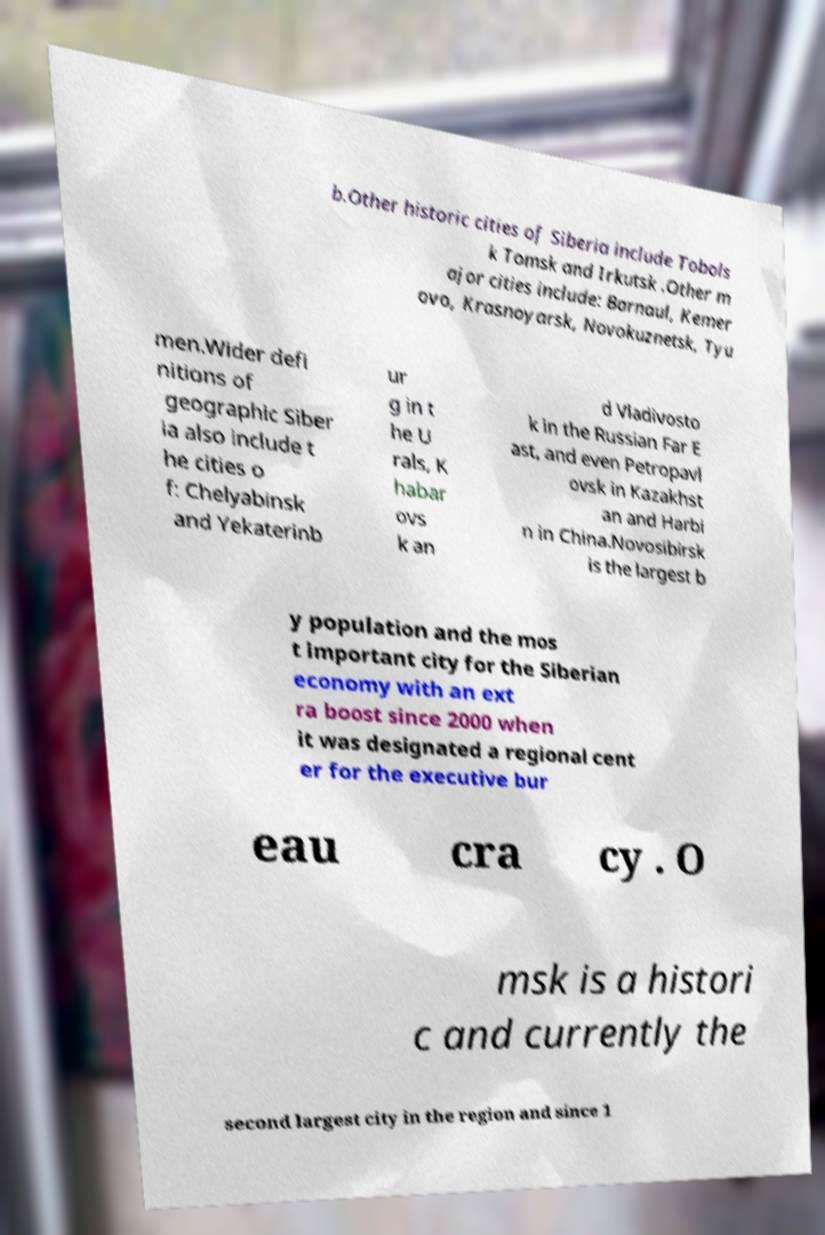Please read and relay the text visible in this image. What does it say? b.Other historic cities of Siberia include Tobols k Tomsk and Irkutsk .Other m ajor cities include: Barnaul, Kemer ovo, Krasnoyarsk, Novokuznetsk, Tyu men.Wider defi nitions of geographic Siber ia also include t he cities o f: Chelyabinsk and Yekaterinb ur g in t he U rals, K habar ovs k an d Vladivosto k in the Russian Far E ast, and even Petropavl ovsk in Kazakhst an and Harbi n in China.Novosibirsk is the largest b y population and the mos t important city for the Siberian economy with an ext ra boost since 2000 when it was designated a regional cent er for the executive bur eau cra cy . O msk is a histori c and currently the second largest city in the region and since 1 